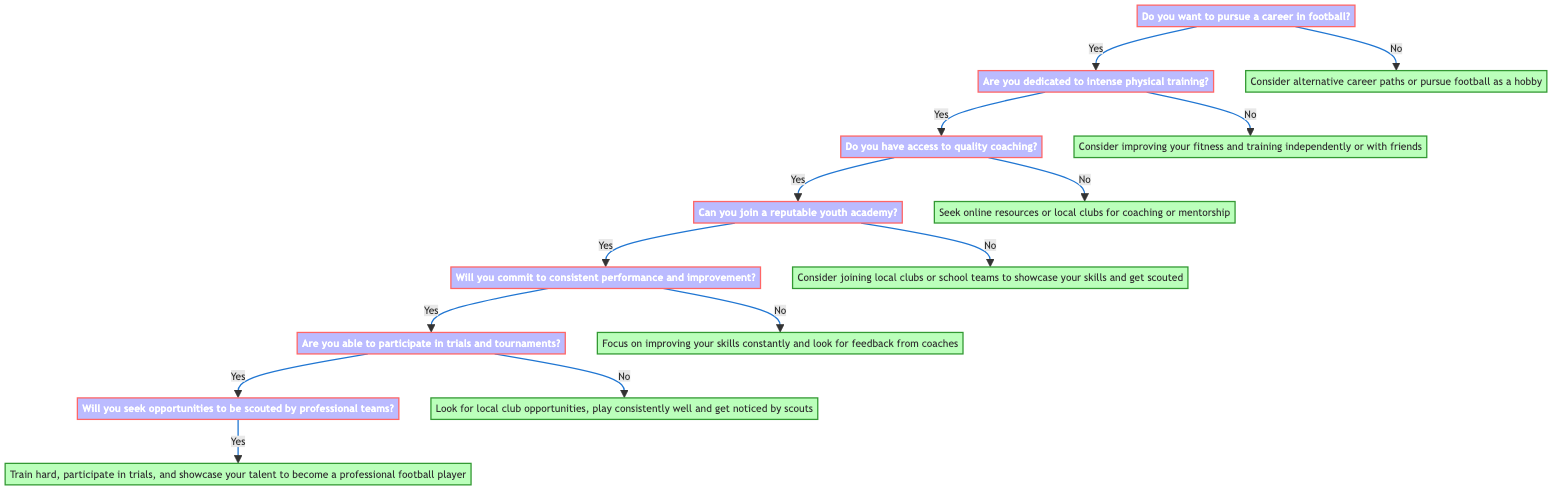What is the first decision in the diagram? The first decision node is "Do you want to pursue a career in football?" which is the root of the diagram.
Answer: Do you want to pursue a career in football? How many nodes are present in the diagram? Counting the nodes, I see that there are a total of 12 nodes, including both decision and endpoint nodes.
Answer: 12 What is the outcome if someone says "yes" to having access to quality coaching? If the answer is "yes" to having access to quality coaching, the next decision would be "Can you join a reputable youth academy?" indicating a positive path forward in the decision tree.
Answer: Can you join a reputable youth academy? If someone is not dedicated to intense physical training, what is suggested? If someone answers "no" to being dedicated to intense physical training, the suggestion is to "Consider improving your fitness and training independently or with friends." which indicates an alternative approach.
Answer: Consider improving your fitness and training independently or with friends What happens if the response to participating in trials and tournaments is "no"? If the response is "no" to participating in trials and tournaments, the next suggestion is to "Look for local club opportunities, play consistently well and get noticed by scouts," guiding individuals to alternative means of getting scouted.
Answer: Look for local club opportunities, play consistently well and get noticed by scouts 